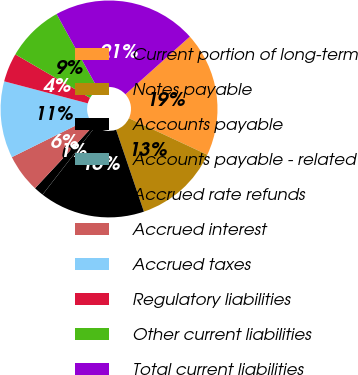<chart> <loc_0><loc_0><loc_500><loc_500><pie_chart><fcel>Current portion of long-term<fcel>Notes payable<fcel>Accounts payable<fcel>Accounts payable - related<fcel>Accrued rate refunds<fcel>Accrued interest<fcel>Accrued taxes<fcel>Regulatory liabilities<fcel>Other current liabilities<fcel>Total current liabilities<nl><fcel>18.56%<fcel>12.85%<fcel>15.71%<fcel>0.01%<fcel>1.44%<fcel>5.72%<fcel>11.43%<fcel>4.29%<fcel>8.57%<fcel>21.42%<nl></chart> 